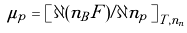Convert formula to latex. <formula><loc_0><loc_0><loc_500><loc_500>\mu _ { p } = \left [ \, \partial ( n _ { B } F ) / \partial n _ { p } \, \right ] _ { T , n _ { n } }</formula> 